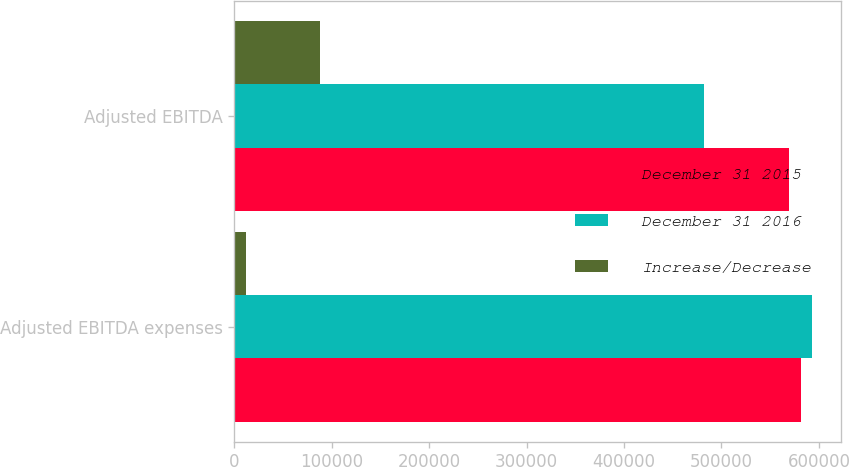<chart> <loc_0><loc_0><loc_500><loc_500><stacked_bar_chart><ecel><fcel>Adjusted EBITDA expenses<fcel>Adjusted EBITDA<nl><fcel>December 31 2015<fcel>581212<fcel>569457<nl><fcel>December 31 2016<fcel>593316<fcel>481697<nl><fcel>Increase/Decrease<fcel>12104<fcel>87760<nl></chart> 